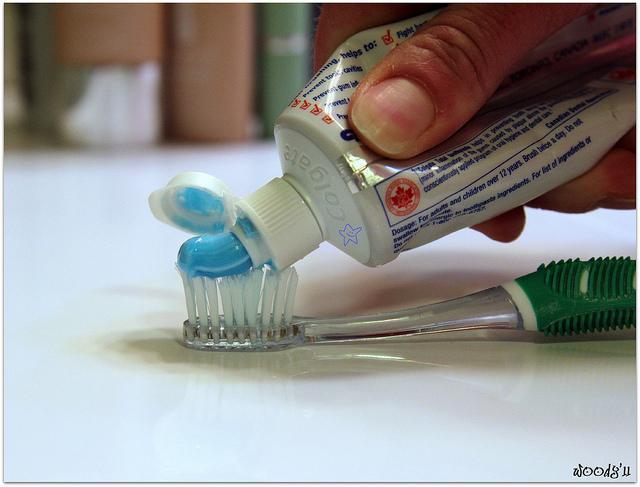How many toothbrushes are visible?
Give a very brief answer. 1. 